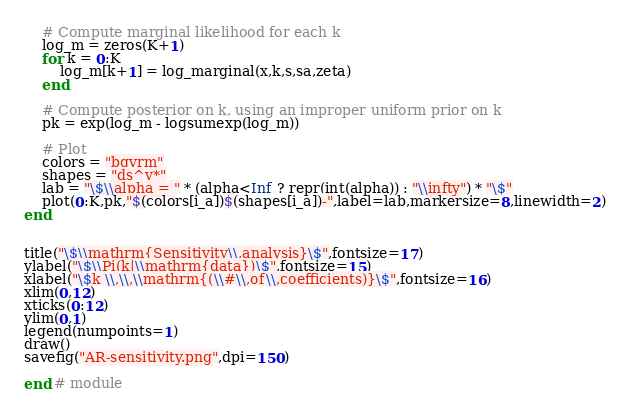Convert code to text. <code><loc_0><loc_0><loc_500><loc_500><_Julia_>
    # Compute marginal likelihood for each k
    log_m = zeros(K+1)
    for k = 0:K
        log_m[k+1] = log_marginal(x,k,s,sa,zeta)
    end

    # Compute posterior on k, using an improper uniform prior on k
    pk = exp(log_m - logsumexp(log_m))

    # Plot
    colors = "bgyrm"
    shapes = "ds^v*"
    lab = "\$\\alpha = " * (alpha<Inf ? repr(int(alpha)) : "\\infty") * "\$"
    plot(0:K,pk,"$(colors[i_a])$(shapes[i_a])-",label=lab,markersize=8,linewidth=2)
end


title("\$\\mathrm{Sensitivity\\,analysis}\$",fontsize=17)
ylabel("\$\\Pi(k|\\mathrm{data})\$",fontsize=15)
xlabel("\$k \\,\\,\\mathrm{(\\#\\,of\\,coefficients)}\$",fontsize=16)
xlim(0,12)
xticks(0:12)
ylim(0,1)
legend(numpoints=1)
draw()
savefig("AR-sensitivity.png",dpi=150)

end # module


</code> 